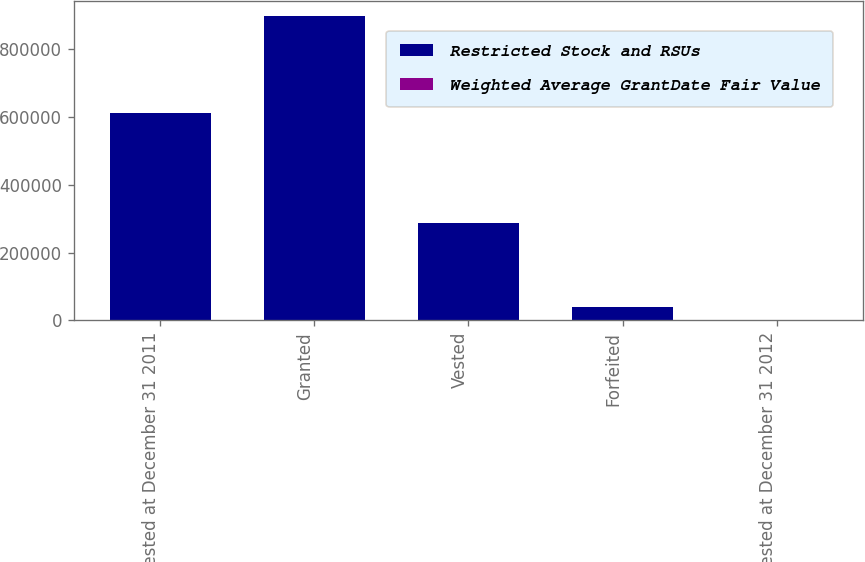Convert chart to OTSL. <chart><loc_0><loc_0><loc_500><loc_500><stacked_bar_chart><ecel><fcel>Non-vested at December 31 2011<fcel>Granted<fcel>Vested<fcel>Forfeited<fcel>Non-vested at December 31 2012<nl><fcel>Restricted Stock and RSUs<fcel>610951<fcel>898093<fcel>286931<fcel>41038<fcel>30.08<nl><fcel>Weighted Average GrantDate Fair Value<fcel>28.85<fcel>30.08<fcel>28.91<fcel>27.51<fcel>29.89<nl></chart> 